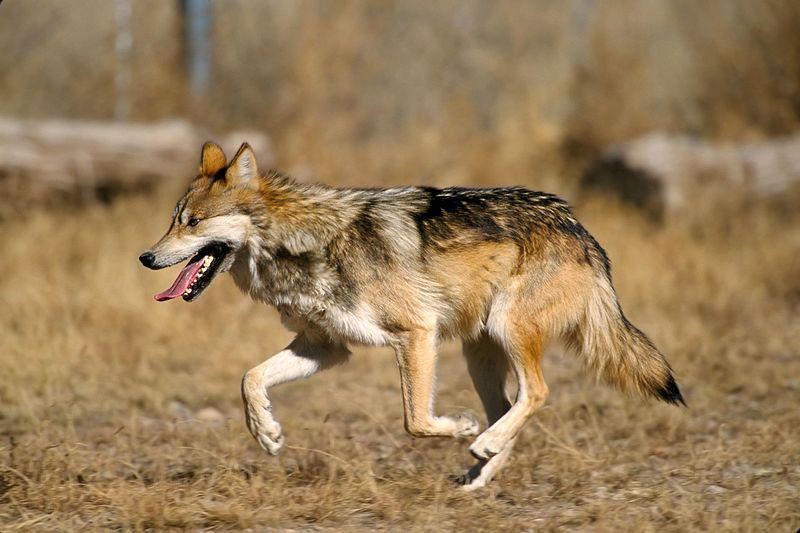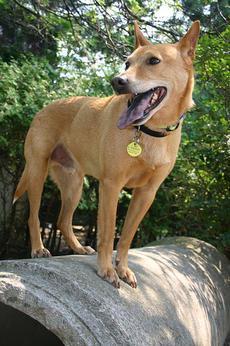The first image is the image on the left, the second image is the image on the right. Examine the images to the left and right. Is the description "The dog on the right image has its mouth wide open." accurate? Answer yes or no. Yes. 